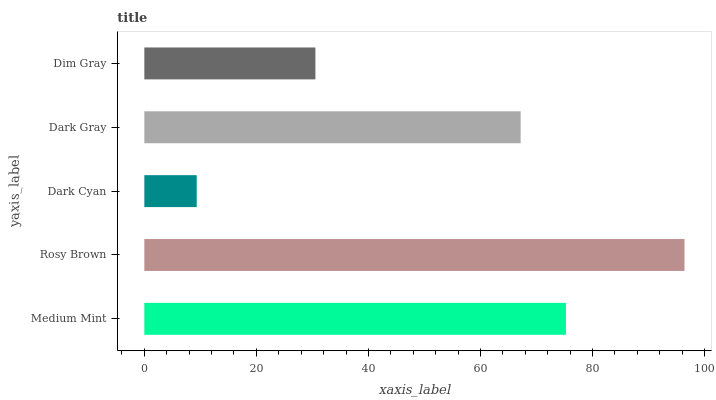Is Dark Cyan the minimum?
Answer yes or no. Yes. Is Rosy Brown the maximum?
Answer yes or no. Yes. Is Rosy Brown the minimum?
Answer yes or no. No. Is Dark Cyan the maximum?
Answer yes or no. No. Is Rosy Brown greater than Dark Cyan?
Answer yes or no. Yes. Is Dark Cyan less than Rosy Brown?
Answer yes or no. Yes. Is Dark Cyan greater than Rosy Brown?
Answer yes or no. No. Is Rosy Brown less than Dark Cyan?
Answer yes or no. No. Is Dark Gray the high median?
Answer yes or no. Yes. Is Dark Gray the low median?
Answer yes or no. Yes. Is Dark Cyan the high median?
Answer yes or no. No. Is Rosy Brown the low median?
Answer yes or no. No. 